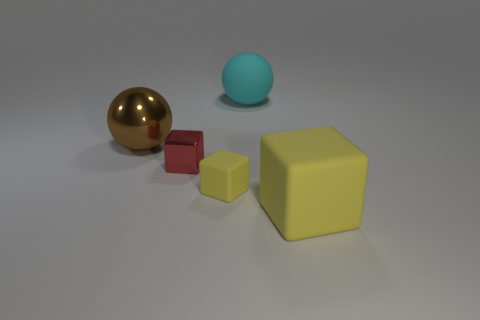Subtract all yellow matte blocks. How many blocks are left? 1 Subtract all red blocks. How many blocks are left? 2 Subtract all cubes. How many objects are left? 2 Subtract 2 balls. How many balls are left? 0 Add 3 large balls. How many objects exist? 8 Subtract 0 gray balls. How many objects are left? 5 Subtract all gray balls. Subtract all brown cylinders. How many balls are left? 2 Subtract all cyan blocks. How many brown spheres are left? 1 Subtract all brown metal objects. Subtract all big purple metal cubes. How many objects are left? 4 Add 1 yellow matte blocks. How many yellow matte blocks are left? 3 